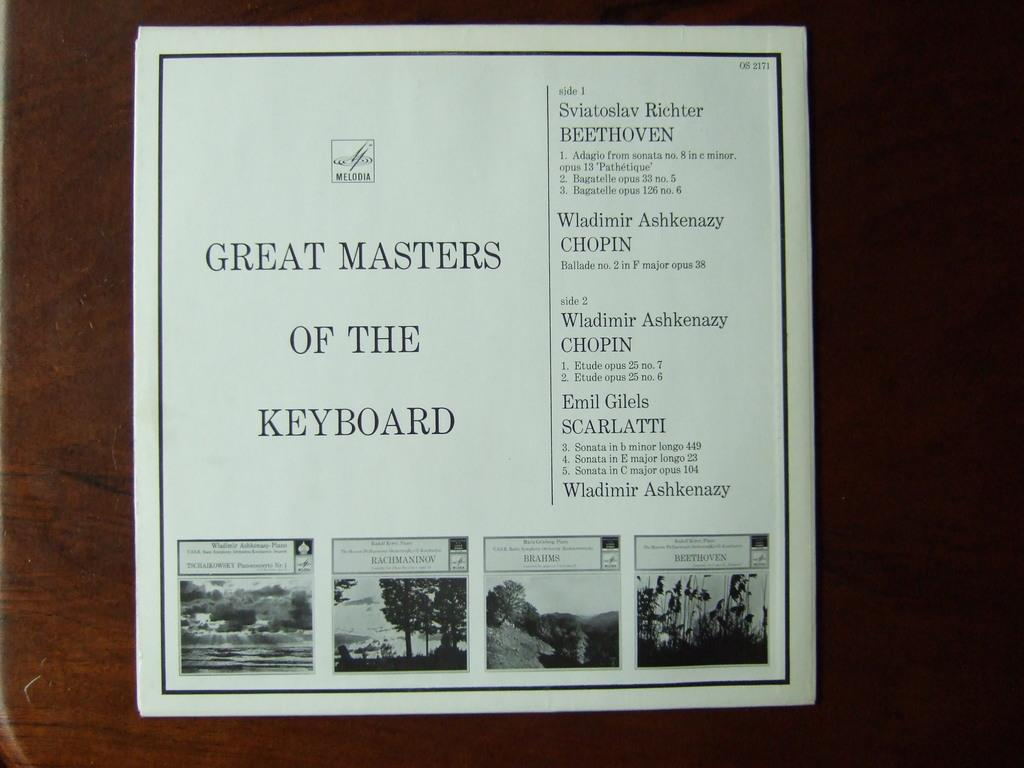What is present on the wooden object in the image? There is a paper on the wooden object in the image. What can be found on the paper? The paper has images and writing on it. What type of basin is shown in the image? There is no basin present in the image. 